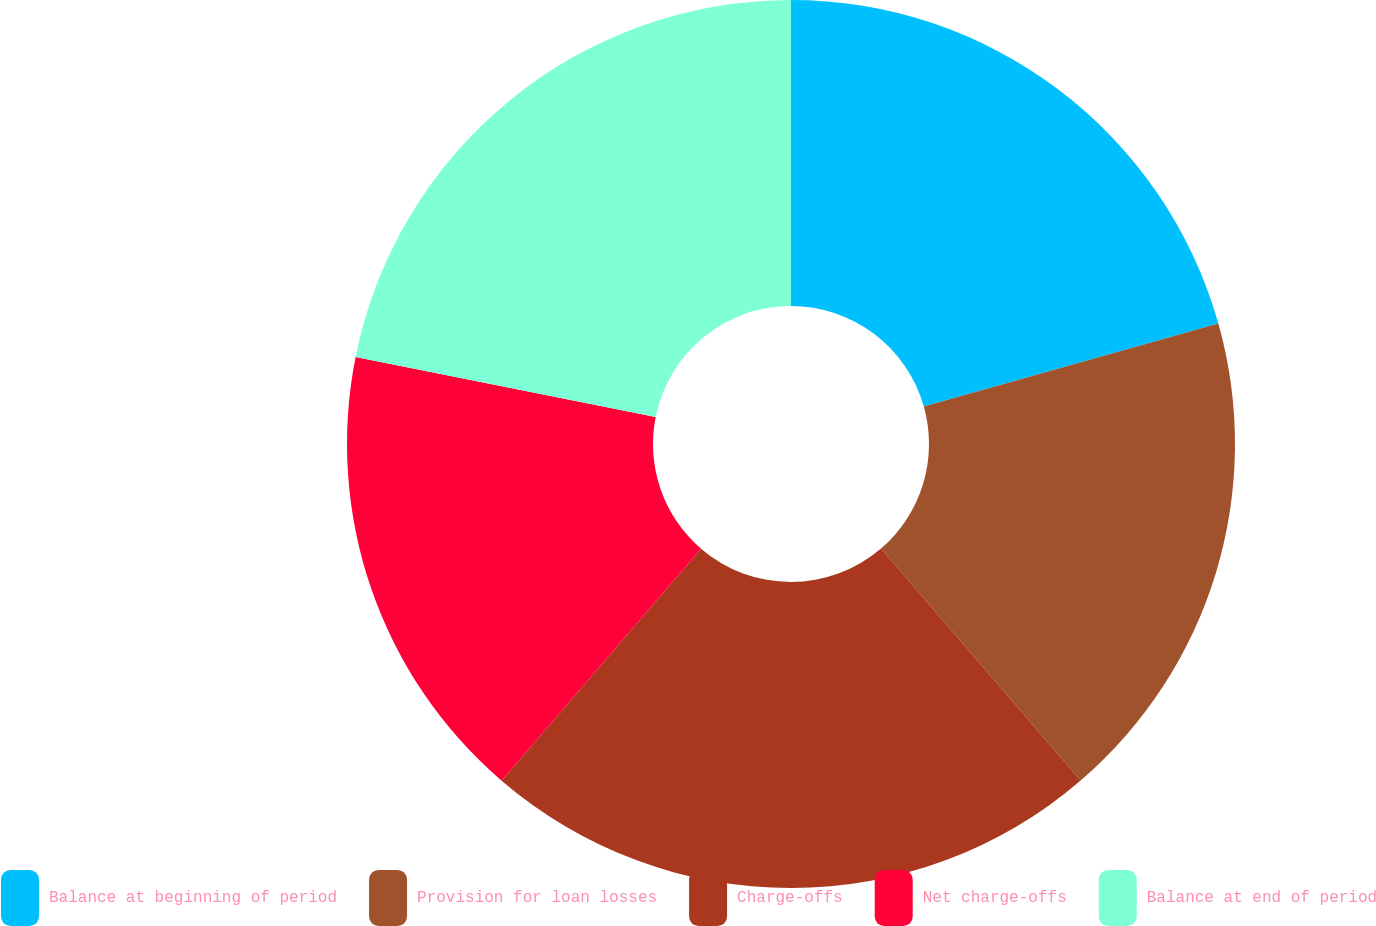Convert chart. <chart><loc_0><loc_0><loc_500><loc_500><pie_chart><fcel>Balance at beginning of period<fcel>Provision for loan losses<fcel>Charge-offs<fcel>Net charge-offs<fcel>Balance at end of period<nl><fcel>20.63%<fcel>18.06%<fcel>22.61%<fcel>16.84%<fcel>21.86%<nl></chart> 